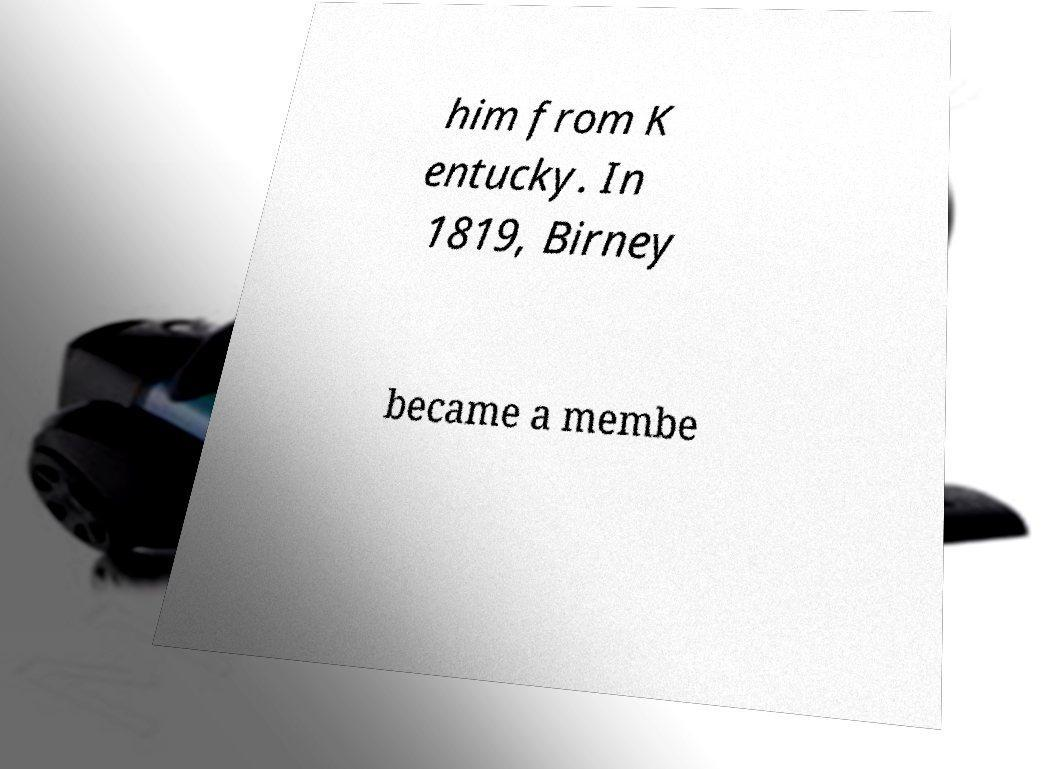I need the written content from this picture converted into text. Can you do that? him from K entucky. In 1819, Birney became a membe 